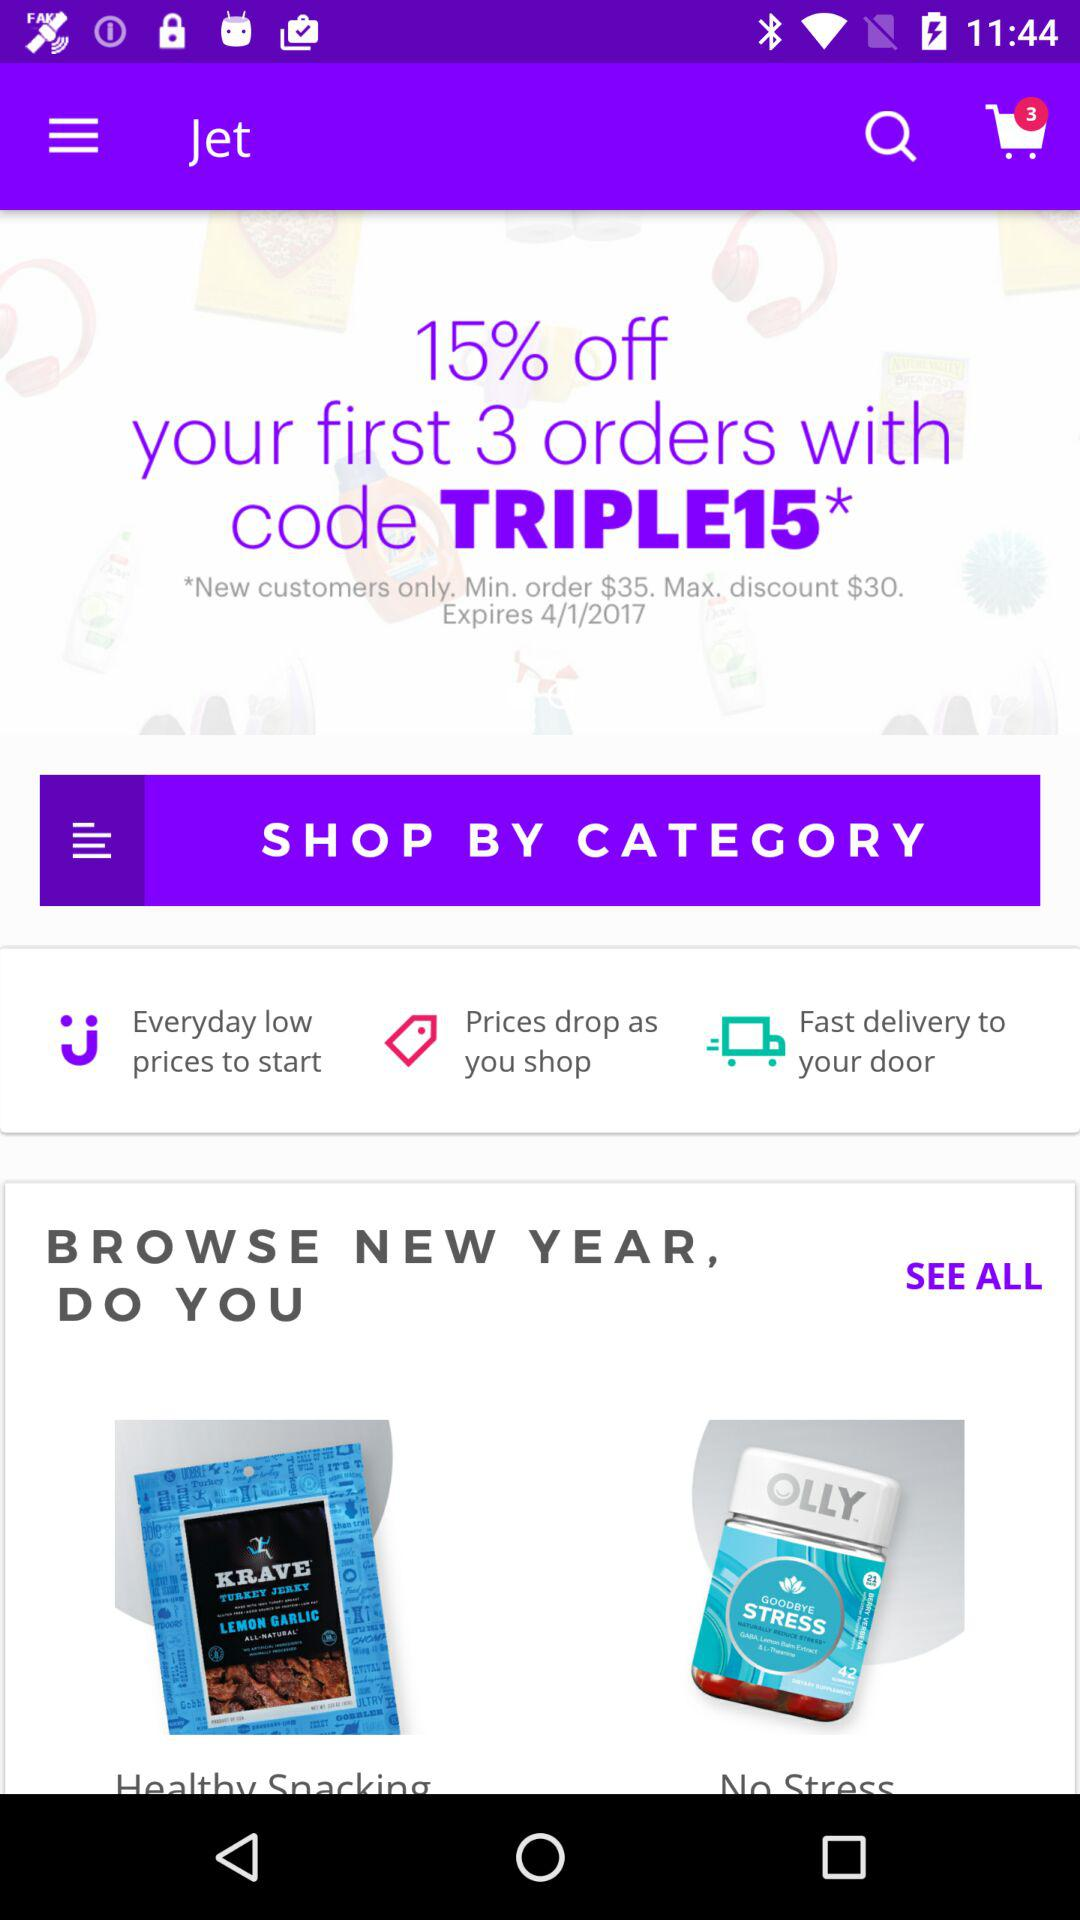What will be the maximum discount? The maximum discount is $30. 